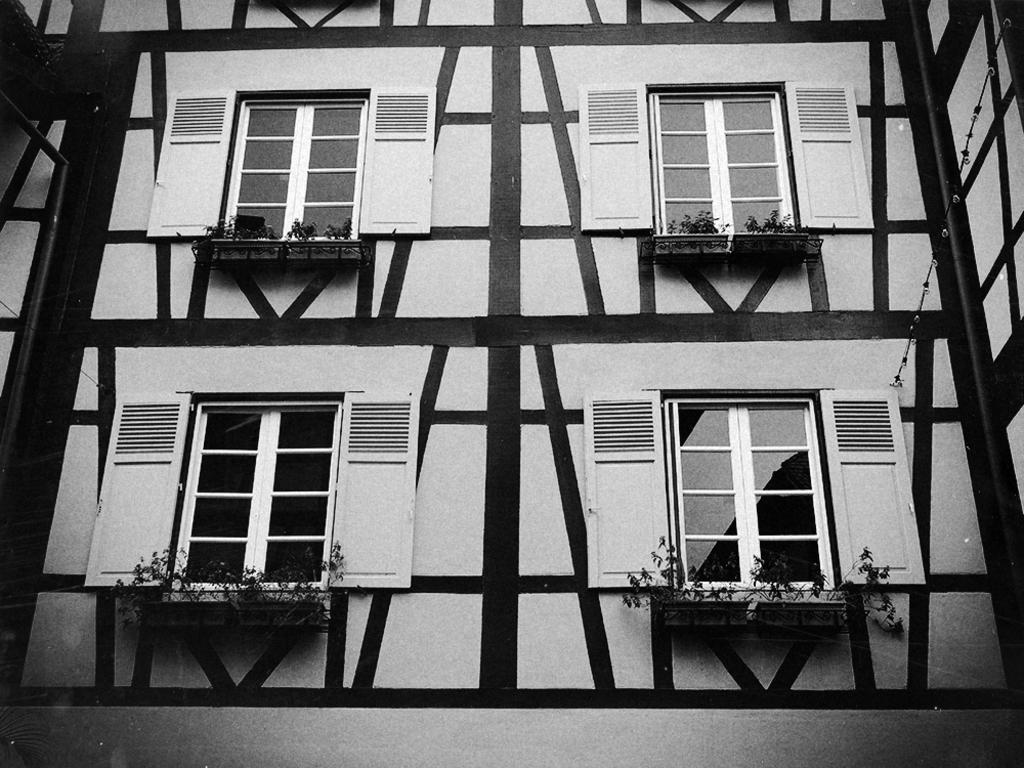What is the color scheme of the image? The image is black and white. What structure can be seen in the image? There is a building in the image. What architectural features are present on the building? The building has windows and pillars. What type of vegetation is visible in the image? There are plants in the image. Can you tell me where the library is located in the image? There is no library present in the image; it features a building with windows and pillars. Is there a minister in the image? There is no minister present in the image; it features a building with windows and pillars. 